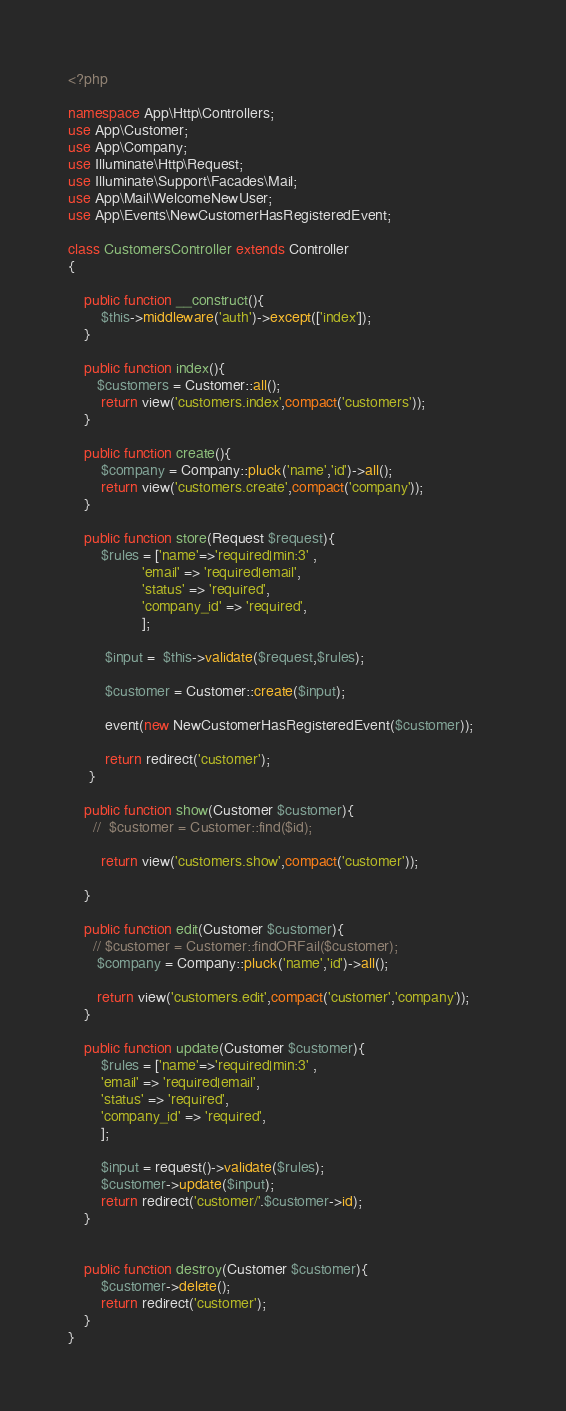Convert code to text. <code><loc_0><loc_0><loc_500><loc_500><_PHP_><?php

namespace App\Http\Controllers;
use App\Customer;
use App\Company;
use Illuminate\Http\Request;
use Illuminate\Support\Facades\Mail;
use App\Mail\WelcomeNewUser;
use App\Events\NewCustomerHasRegisteredEvent;

class CustomersController extends Controller
{

    public function __construct(){
        $this->middleware('auth')->except(['index']);
    }

    public function index(){
       $customers = Customer::all();
        return view('customers.index',compact('customers'));
    }

    public function create(){       
        $company = Company::pluck('name','id')->all();
        return view('customers.create',compact('company'));
    }

    public function store(Request $request){
        $rules = ['name'=>'required|min:3' ,
                  'email' => 'required|email',
                  'status' => 'required',
                  'company_id' => 'required',
                  ];   
 
         $input =  $this->validate($request,$rules);                 
                 
         $customer = Customer::create($input);        
     
         event(new NewCustomerHasRegisteredEvent($customer));      
         
         return redirect('customer');
     }

    public function show(Customer $customer){
      //  $customer = Customer::find($id);

        return view('customers.show',compact('customer'));

    }

    public function edit(Customer $customer){
      // $customer = Customer::findORFail($customer);
       $company = Company::pluck('name','id')->all();

       return view('customers.edit',compact('customer','company'));
    }

    public function update(Customer $customer){
        $rules = ['name'=>'required|min:3' ,
        'email' => 'required|email',
        'status' => 'required',
        'company_id' => 'required',
        ];   

        $input = request()->validate($rules);             
        $customer->update($input);        
        return redirect('customer/'.$customer->id);
    }   


    public function destroy(Customer $customer){
        $customer->delete();
        return redirect('customer');
    }
}
</code> 